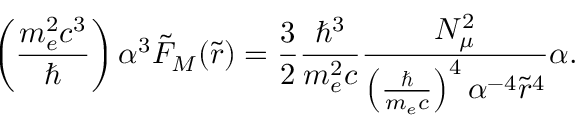Convert formula to latex. <formula><loc_0><loc_0><loc_500><loc_500>\left ( \frac { m _ { e } ^ { 2 } c ^ { 3 } } { } \right ) \alpha ^ { 3 } \tilde { F } _ { M } ( \tilde { r } ) = \frac { 3 } { 2 } \frac { \hbar { ^ } { 3 } } { m _ { e } ^ { 2 } c } \frac { N _ { \mu } ^ { 2 } } { \left ( \frac { } { m _ { e } c } \right ) ^ { 4 } \alpha ^ { - 4 } \tilde { r } ^ { 4 } } \alpha .</formula> 